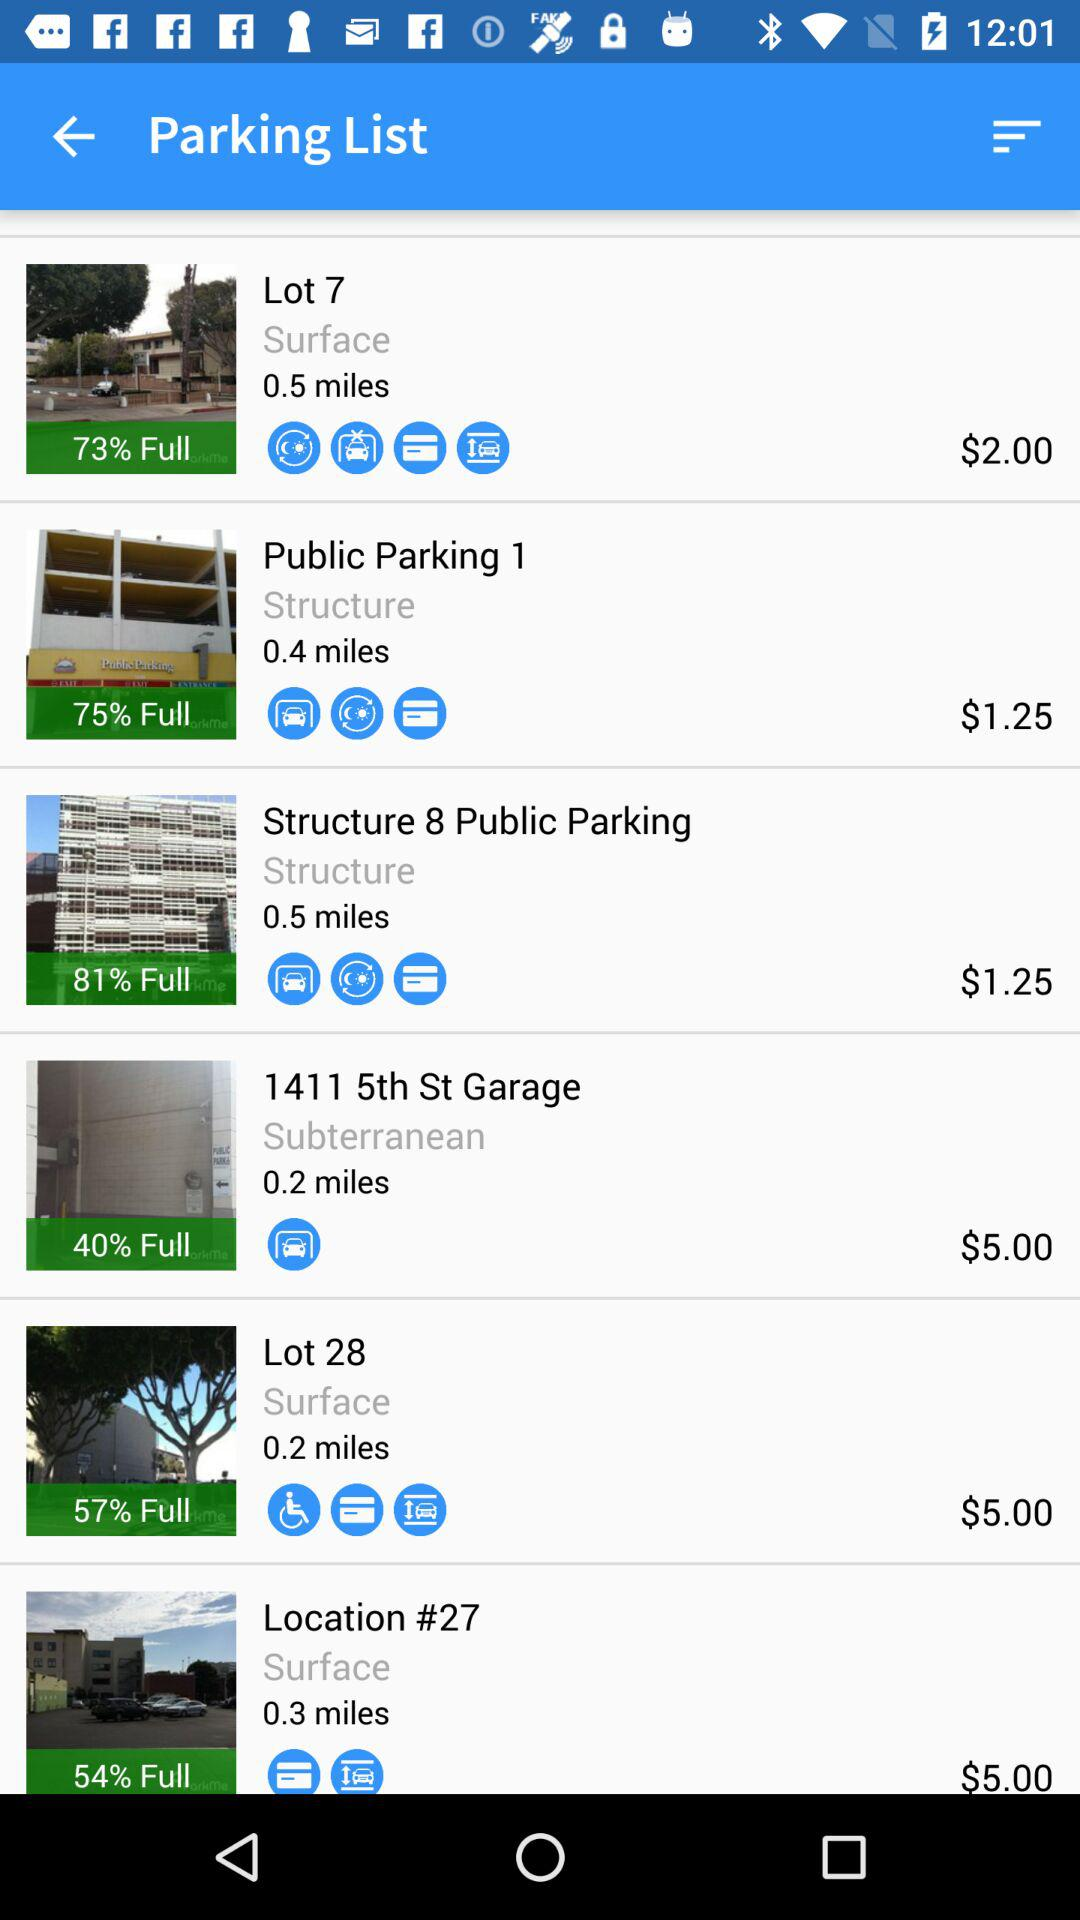Which parking lot has the parking charge of $2.00? The parking lot that has the parking charge of $2.00 is Lot 7. 